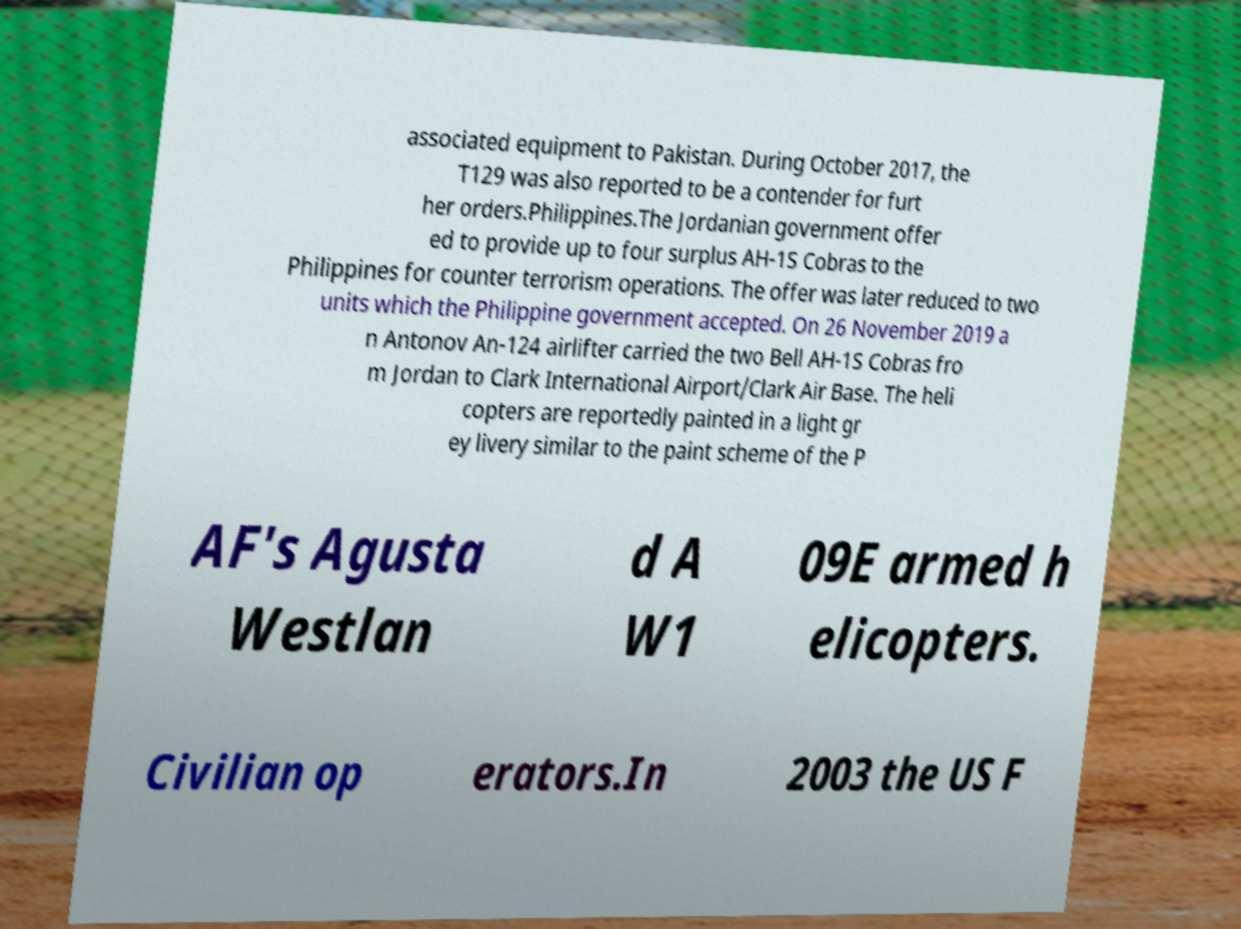For documentation purposes, I need the text within this image transcribed. Could you provide that? associated equipment to Pakistan. During October 2017, the T129 was also reported to be a contender for furt her orders.Philippines.The Jordanian government offer ed to provide up to four surplus AH-1S Cobras to the Philippines for counter terrorism operations. The offer was later reduced to two units which the Philippine government accepted. On 26 November 2019 a n Antonov An-124 airlifter carried the two Bell AH-1S Cobras fro m Jordan to Clark International Airport/Clark Air Base. The heli copters are reportedly painted in a light gr ey livery similar to the paint scheme of the P AF's Agusta Westlan d A W1 09E armed h elicopters. Civilian op erators.In 2003 the US F 